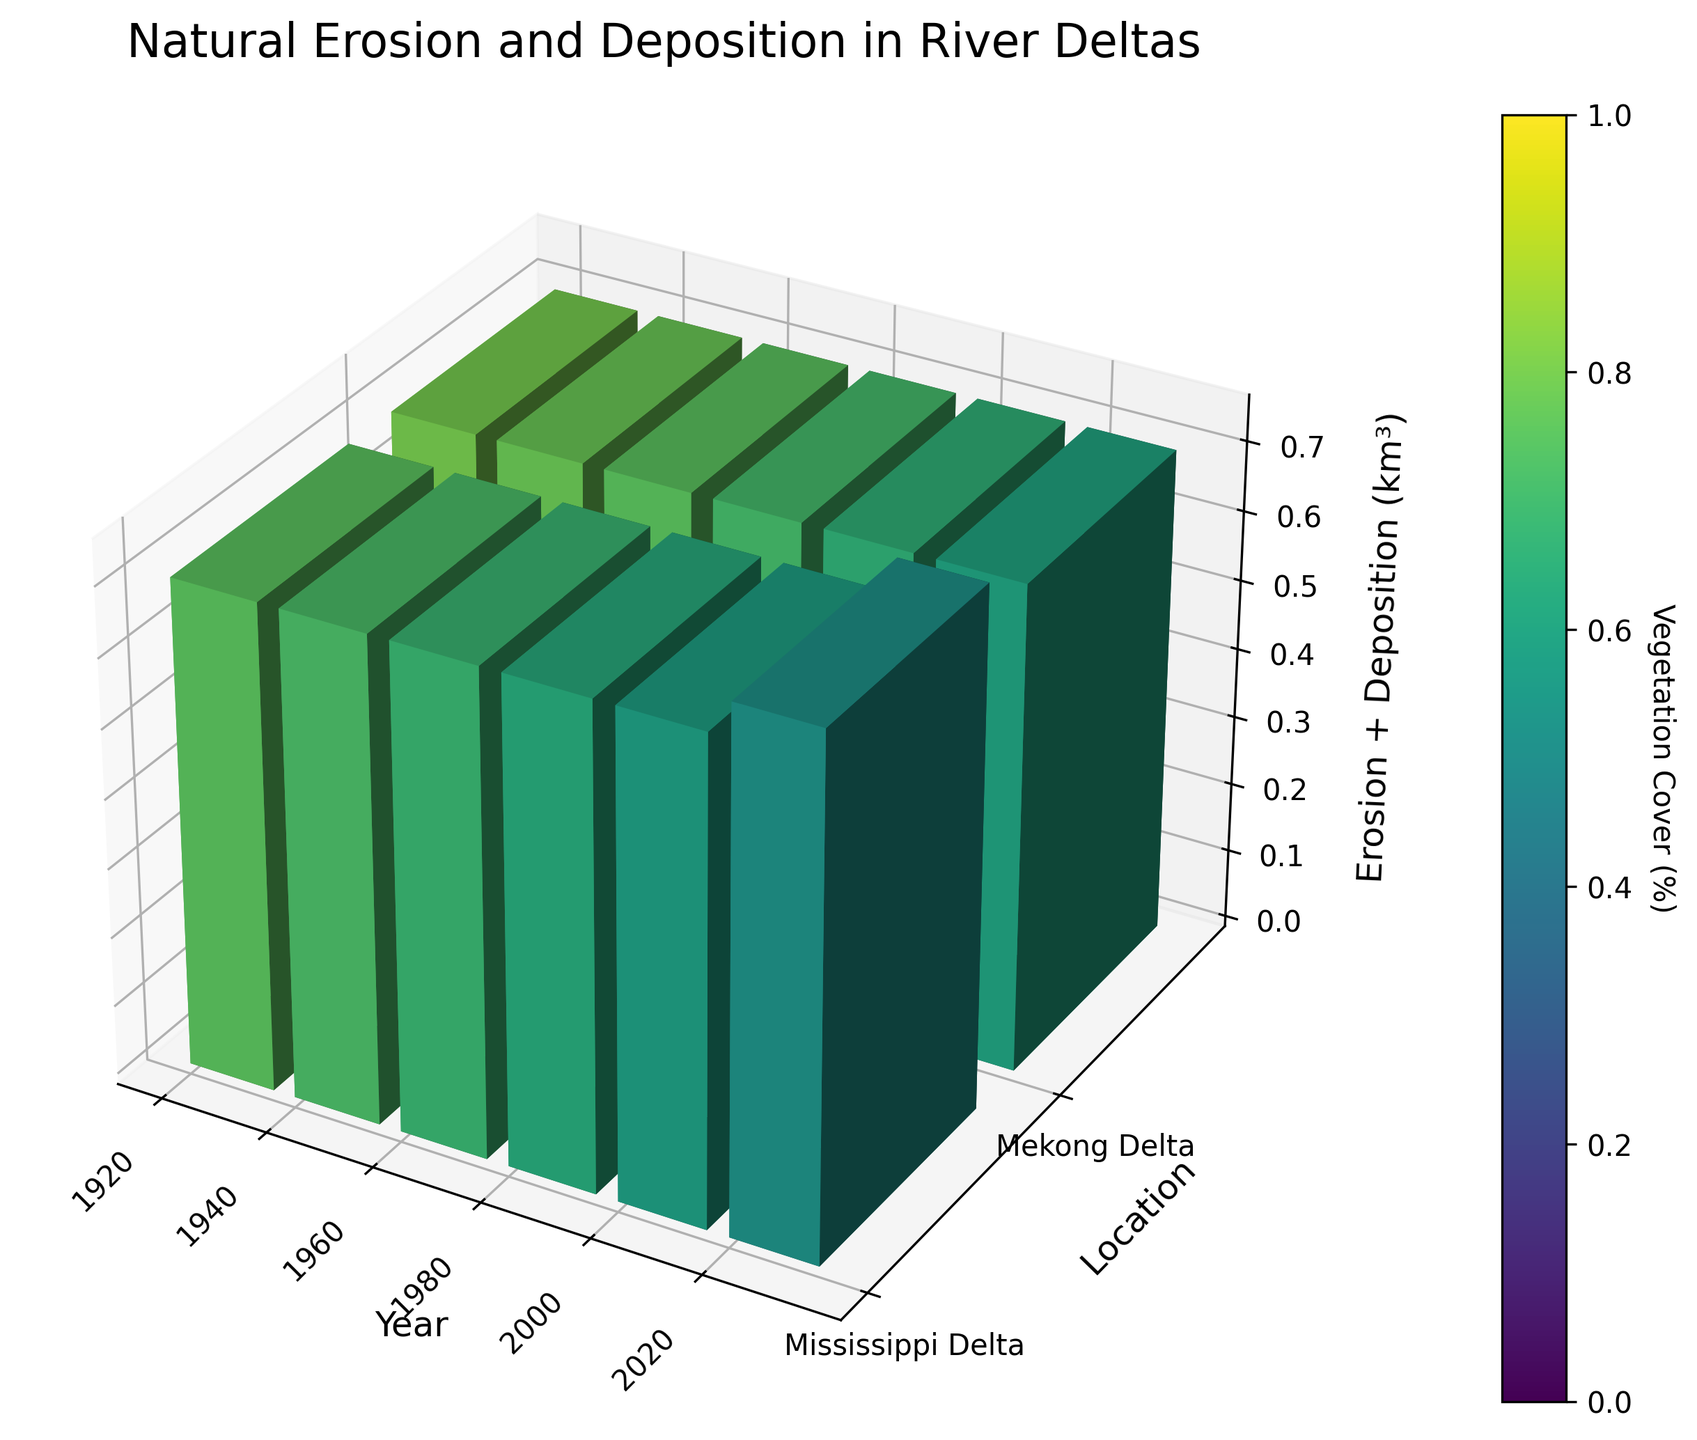How many years are represented in the figure? The x-axis of the figure shows the range of years. There are discrete points corresponding to each year labeled on the x-axis. Counting these distinct points, we note that the years are 1920, 1940, 1960, 1980, 2000, and 2020. So, there are 6 years represented in total.
Answer: 6 What river delta shows a higher rate of erosion over time? To determine which river delta has a higher rate of erosion, examine the erosion values for each delta over the years. The erosion values for the Mississippi Delta increase from 0.2 km³ in 1920 to 0.7 km³ in 2020, while for the Mekong Delta, they increase from 0.1 km³ to 0.6 km³ over the same period. Thus, the Mississippi Delta shows a higher erosion rate over time.
Answer: Mississippi Delta What is the total volume of material (erosion + deposition) in the Mississippi Delta in 2000? To find the total volume of material in the Mississippi Delta in 2000, sum the erosion and deposition volumes for that year. The erosion volume is 0.6 km³, and the deposition volume is 0.1 km³. Therefore, the total volume is 0.6 + 0.1 = 0.7 km³.
Answer: 0.7 km³ How does vegetation cover change in the Mekong Delta from 1920 to 2020? To analyze the change in vegetation cover for the Mekong Delta, observe the vegetation cover values for the years 1920 and 2020. In 1920, the vegetation cover is 80%, and in 2020, it is 60%. The decrease can be calculated as 80% - 60% = 20%. So, it decreases by 20%.
Answer: Decreases by 20% Which year has the maximum deposition volume for the Mekong Delta? Look at the deposition values for the Mekong Delta across all the years. The highest deposition is 0.6 km³ in 1920. So, 1920 has the maximum deposition volume.
Answer: 1920 Compare the erosion volumes in 1960 between the Mississippi and Mekong Deltas. To compare the erosion volumes, check the values for 1960 for both deltas. The erosion volume for the Mississippi Delta is 0.4 km³, while for the Mekong Delta, it is 0.3 km³. Thus, the Mississippi Delta has a higher erosion volume in 1960.
Answer: Mississippi Delta In which year did vegetation cover drop below 70% in the Mississippi Delta? Examine the vegetation cover values for the Mississippi Delta and find the first year when the value falls below 70%. The cover in 1960 is 68%.
Answer: 1960 How much more material (erosion + deposition) was present in the Mississippi Delta in 1940 compared to the Mekong Delta in the same year? Calculate the total material volume for both deltas in 1940 by summing the erosion and deposition values. For the Mississippi Delta: 0.3 + 0.4 = 0.7 km³. For the Mekong Delta: 0.2 + 0.5 = 0.7 km³. The difference is 0.7 - 0.7 = 0 km³. So, no difference.
Answer: 0 km³ What is the average vegetation cover over the years for the Mekong Delta? To find the average vegetation cover, sum the vegetation cover percentages for the Mekong Delta and divide by the number of years. The cover values are 80%, 78%, 75%, 71%, 66%, and 60%. The sum is 430%, and dividing by 6 gives an average of 430/6 = 71.67%.
Answer: 71.67% 